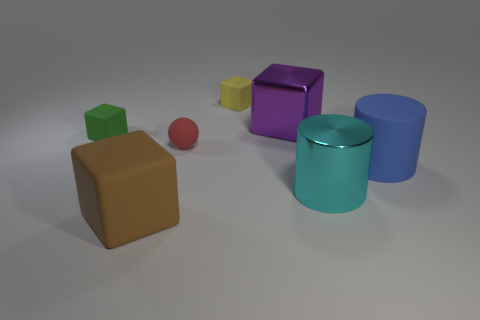Is the color of the large thing to the left of the red matte ball the same as the rubber object that is on the right side of the cyan cylinder?
Offer a terse response. No. How many cyan things are either tiny rubber cubes or cylinders?
Offer a very short reply. 1. Is the shape of the large purple object the same as the large matte thing that is behind the big brown cube?
Your answer should be compact. No. What shape is the big purple object?
Offer a terse response. Cube. There is a blue cylinder that is the same size as the brown object; what is it made of?
Offer a terse response. Rubber. Are there any other things that have the same size as the cyan cylinder?
Provide a succinct answer. Yes. How many things are either green rubber things or rubber things that are on the left side of the large cyan object?
Offer a terse response. 4. What size is the cyan thing that is made of the same material as the purple object?
Make the answer very short. Large. The big matte thing on the right side of the big cube that is in front of the purple thing is what shape?
Make the answer very short. Cylinder. What size is the rubber thing that is both behind the red rubber ball and to the right of the big brown rubber block?
Offer a terse response. Small. 